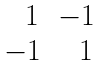<formula> <loc_0><loc_0><loc_500><loc_500>\begin{matrix} { \ \ } 1 & - 1 \\ - 1 & { \ \ } 1 \end{matrix}</formula> 